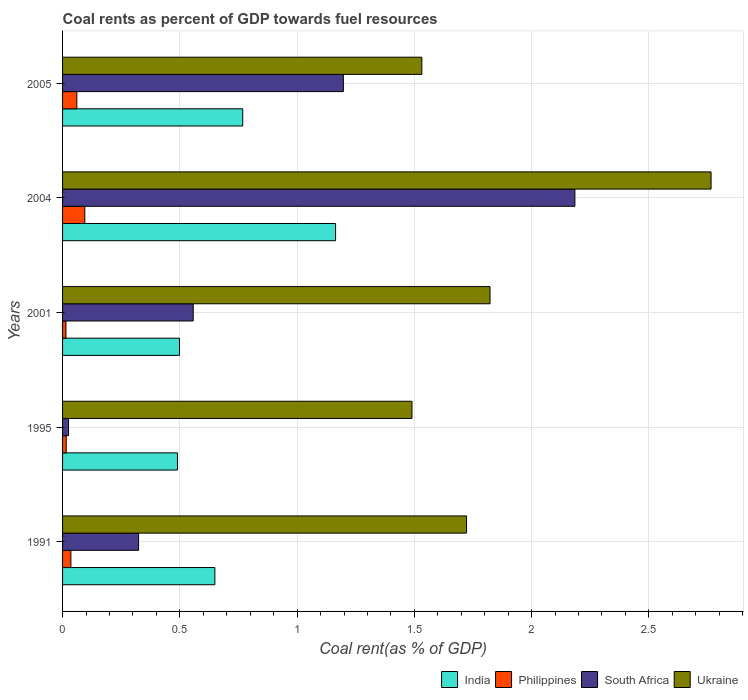How many different coloured bars are there?
Make the answer very short. 4. Are the number of bars on each tick of the Y-axis equal?
Your answer should be compact. Yes. How many bars are there on the 1st tick from the top?
Give a very brief answer. 4. How many bars are there on the 3rd tick from the bottom?
Provide a short and direct response. 4. What is the label of the 3rd group of bars from the top?
Offer a very short reply. 2001. In how many cases, is the number of bars for a given year not equal to the number of legend labels?
Make the answer very short. 0. What is the coal rent in India in 2004?
Your response must be concise. 1.16. Across all years, what is the maximum coal rent in South Africa?
Ensure brevity in your answer.  2.18. Across all years, what is the minimum coal rent in Ukraine?
Your response must be concise. 1.49. In which year was the coal rent in India maximum?
Offer a terse response. 2004. In which year was the coal rent in India minimum?
Make the answer very short. 1995. What is the total coal rent in India in the graph?
Ensure brevity in your answer.  3.57. What is the difference between the coal rent in Philippines in 2004 and that in 2005?
Offer a very short reply. 0.03. What is the difference between the coal rent in Ukraine in 2005 and the coal rent in India in 1991?
Your response must be concise. 0.88. What is the average coal rent in India per year?
Keep it short and to the point. 0.71. In the year 1991, what is the difference between the coal rent in Ukraine and coal rent in India?
Your answer should be compact. 1.07. What is the ratio of the coal rent in Ukraine in 1995 to that in 2001?
Offer a terse response. 0.82. Is the coal rent in Philippines in 1991 less than that in 2005?
Provide a succinct answer. Yes. What is the difference between the highest and the second highest coal rent in Philippines?
Provide a short and direct response. 0.03. What is the difference between the highest and the lowest coal rent in Ukraine?
Give a very brief answer. 1.28. Is the sum of the coal rent in Philippines in 2001 and 2005 greater than the maximum coal rent in Ukraine across all years?
Your answer should be very brief. No. What does the 1st bar from the top in 1995 represents?
Your answer should be very brief. Ukraine. Is it the case that in every year, the sum of the coal rent in Philippines and coal rent in South Africa is greater than the coal rent in Ukraine?
Provide a short and direct response. No. Are all the bars in the graph horizontal?
Your response must be concise. Yes. How many years are there in the graph?
Ensure brevity in your answer.  5. How many legend labels are there?
Keep it short and to the point. 4. How are the legend labels stacked?
Provide a succinct answer. Horizontal. What is the title of the graph?
Your answer should be very brief. Coal rents as percent of GDP towards fuel resources. Does "Equatorial Guinea" appear as one of the legend labels in the graph?
Make the answer very short. No. What is the label or title of the X-axis?
Give a very brief answer. Coal rent(as % of GDP). What is the label or title of the Y-axis?
Make the answer very short. Years. What is the Coal rent(as % of GDP) in India in 1991?
Your response must be concise. 0.65. What is the Coal rent(as % of GDP) of Philippines in 1991?
Provide a succinct answer. 0.04. What is the Coal rent(as % of GDP) of South Africa in 1991?
Give a very brief answer. 0.32. What is the Coal rent(as % of GDP) in Ukraine in 1991?
Your response must be concise. 1.72. What is the Coal rent(as % of GDP) of India in 1995?
Keep it short and to the point. 0.49. What is the Coal rent(as % of GDP) in Philippines in 1995?
Give a very brief answer. 0.02. What is the Coal rent(as % of GDP) in South Africa in 1995?
Your response must be concise. 0.03. What is the Coal rent(as % of GDP) of Ukraine in 1995?
Keep it short and to the point. 1.49. What is the Coal rent(as % of GDP) of India in 2001?
Your answer should be compact. 0.5. What is the Coal rent(as % of GDP) in Philippines in 2001?
Keep it short and to the point. 0.01. What is the Coal rent(as % of GDP) in South Africa in 2001?
Give a very brief answer. 0.56. What is the Coal rent(as % of GDP) of Ukraine in 2001?
Ensure brevity in your answer.  1.82. What is the Coal rent(as % of GDP) in India in 2004?
Make the answer very short. 1.16. What is the Coal rent(as % of GDP) in Philippines in 2004?
Provide a short and direct response. 0.09. What is the Coal rent(as % of GDP) in South Africa in 2004?
Offer a very short reply. 2.18. What is the Coal rent(as % of GDP) in Ukraine in 2004?
Provide a short and direct response. 2.77. What is the Coal rent(as % of GDP) in India in 2005?
Ensure brevity in your answer.  0.77. What is the Coal rent(as % of GDP) of Philippines in 2005?
Keep it short and to the point. 0.06. What is the Coal rent(as % of GDP) of South Africa in 2005?
Make the answer very short. 1.2. What is the Coal rent(as % of GDP) in Ukraine in 2005?
Give a very brief answer. 1.53. Across all years, what is the maximum Coal rent(as % of GDP) of India?
Make the answer very short. 1.16. Across all years, what is the maximum Coal rent(as % of GDP) of Philippines?
Keep it short and to the point. 0.09. Across all years, what is the maximum Coal rent(as % of GDP) of South Africa?
Offer a terse response. 2.18. Across all years, what is the maximum Coal rent(as % of GDP) in Ukraine?
Give a very brief answer. 2.77. Across all years, what is the minimum Coal rent(as % of GDP) in India?
Offer a very short reply. 0.49. Across all years, what is the minimum Coal rent(as % of GDP) of Philippines?
Keep it short and to the point. 0.01. Across all years, what is the minimum Coal rent(as % of GDP) of South Africa?
Provide a short and direct response. 0.03. Across all years, what is the minimum Coal rent(as % of GDP) in Ukraine?
Offer a very short reply. 1.49. What is the total Coal rent(as % of GDP) in India in the graph?
Your answer should be compact. 3.57. What is the total Coal rent(as % of GDP) in Philippines in the graph?
Keep it short and to the point. 0.22. What is the total Coal rent(as % of GDP) of South Africa in the graph?
Your response must be concise. 4.29. What is the total Coal rent(as % of GDP) of Ukraine in the graph?
Provide a short and direct response. 9.33. What is the difference between the Coal rent(as % of GDP) of India in 1991 and that in 1995?
Your response must be concise. 0.16. What is the difference between the Coal rent(as % of GDP) in Philippines in 1991 and that in 1995?
Ensure brevity in your answer.  0.02. What is the difference between the Coal rent(as % of GDP) in South Africa in 1991 and that in 1995?
Keep it short and to the point. 0.3. What is the difference between the Coal rent(as % of GDP) of Ukraine in 1991 and that in 1995?
Provide a succinct answer. 0.23. What is the difference between the Coal rent(as % of GDP) of India in 1991 and that in 2001?
Provide a short and direct response. 0.15. What is the difference between the Coal rent(as % of GDP) of Philippines in 1991 and that in 2001?
Offer a very short reply. 0.02. What is the difference between the Coal rent(as % of GDP) of South Africa in 1991 and that in 2001?
Make the answer very short. -0.23. What is the difference between the Coal rent(as % of GDP) of Ukraine in 1991 and that in 2001?
Your response must be concise. -0.1. What is the difference between the Coal rent(as % of GDP) of India in 1991 and that in 2004?
Ensure brevity in your answer.  -0.51. What is the difference between the Coal rent(as % of GDP) of Philippines in 1991 and that in 2004?
Ensure brevity in your answer.  -0.06. What is the difference between the Coal rent(as % of GDP) of South Africa in 1991 and that in 2004?
Give a very brief answer. -1.86. What is the difference between the Coal rent(as % of GDP) of Ukraine in 1991 and that in 2004?
Your answer should be very brief. -1.04. What is the difference between the Coal rent(as % of GDP) of India in 1991 and that in 2005?
Offer a terse response. -0.12. What is the difference between the Coal rent(as % of GDP) of Philippines in 1991 and that in 2005?
Keep it short and to the point. -0.03. What is the difference between the Coal rent(as % of GDP) of South Africa in 1991 and that in 2005?
Give a very brief answer. -0.87. What is the difference between the Coal rent(as % of GDP) of Ukraine in 1991 and that in 2005?
Provide a succinct answer. 0.19. What is the difference between the Coal rent(as % of GDP) in India in 1995 and that in 2001?
Keep it short and to the point. -0.01. What is the difference between the Coal rent(as % of GDP) in Philippines in 1995 and that in 2001?
Your response must be concise. 0. What is the difference between the Coal rent(as % of GDP) in South Africa in 1995 and that in 2001?
Your response must be concise. -0.53. What is the difference between the Coal rent(as % of GDP) in Ukraine in 1995 and that in 2001?
Offer a very short reply. -0.33. What is the difference between the Coal rent(as % of GDP) in India in 1995 and that in 2004?
Offer a very short reply. -0.67. What is the difference between the Coal rent(as % of GDP) in Philippines in 1995 and that in 2004?
Offer a terse response. -0.08. What is the difference between the Coal rent(as % of GDP) in South Africa in 1995 and that in 2004?
Your answer should be very brief. -2.16. What is the difference between the Coal rent(as % of GDP) of Ukraine in 1995 and that in 2004?
Keep it short and to the point. -1.28. What is the difference between the Coal rent(as % of GDP) of India in 1995 and that in 2005?
Your answer should be compact. -0.28. What is the difference between the Coal rent(as % of GDP) of Philippines in 1995 and that in 2005?
Keep it short and to the point. -0.05. What is the difference between the Coal rent(as % of GDP) in South Africa in 1995 and that in 2005?
Your response must be concise. -1.17. What is the difference between the Coal rent(as % of GDP) in Ukraine in 1995 and that in 2005?
Offer a very short reply. -0.04. What is the difference between the Coal rent(as % of GDP) of India in 2001 and that in 2004?
Your response must be concise. -0.67. What is the difference between the Coal rent(as % of GDP) in Philippines in 2001 and that in 2004?
Provide a succinct answer. -0.08. What is the difference between the Coal rent(as % of GDP) of South Africa in 2001 and that in 2004?
Give a very brief answer. -1.63. What is the difference between the Coal rent(as % of GDP) in Ukraine in 2001 and that in 2004?
Your answer should be compact. -0.94. What is the difference between the Coal rent(as % of GDP) in India in 2001 and that in 2005?
Offer a terse response. -0.27. What is the difference between the Coal rent(as % of GDP) of Philippines in 2001 and that in 2005?
Your response must be concise. -0.05. What is the difference between the Coal rent(as % of GDP) of South Africa in 2001 and that in 2005?
Offer a terse response. -0.64. What is the difference between the Coal rent(as % of GDP) of Ukraine in 2001 and that in 2005?
Offer a very short reply. 0.29. What is the difference between the Coal rent(as % of GDP) of India in 2004 and that in 2005?
Your response must be concise. 0.4. What is the difference between the Coal rent(as % of GDP) in Philippines in 2004 and that in 2005?
Ensure brevity in your answer.  0.03. What is the difference between the Coal rent(as % of GDP) in South Africa in 2004 and that in 2005?
Keep it short and to the point. 0.99. What is the difference between the Coal rent(as % of GDP) of Ukraine in 2004 and that in 2005?
Provide a succinct answer. 1.23. What is the difference between the Coal rent(as % of GDP) in India in 1991 and the Coal rent(as % of GDP) in Philippines in 1995?
Make the answer very short. 0.63. What is the difference between the Coal rent(as % of GDP) in India in 1991 and the Coal rent(as % of GDP) in South Africa in 1995?
Your answer should be compact. 0.62. What is the difference between the Coal rent(as % of GDP) of India in 1991 and the Coal rent(as % of GDP) of Ukraine in 1995?
Offer a terse response. -0.84. What is the difference between the Coal rent(as % of GDP) of Philippines in 1991 and the Coal rent(as % of GDP) of Ukraine in 1995?
Your answer should be compact. -1.45. What is the difference between the Coal rent(as % of GDP) of South Africa in 1991 and the Coal rent(as % of GDP) of Ukraine in 1995?
Your answer should be very brief. -1.17. What is the difference between the Coal rent(as % of GDP) in India in 1991 and the Coal rent(as % of GDP) in Philippines in 2001?
Keep it short and to the point. 0.63. What is the difference between the Coal rent(as % of GDP) in India in 1991 and the Coal rent(as % of GDP) in South Africa in 2001?
Your answer should be compact. 0.09. What is the difference between the Coal rent(as % of GDP) of India in 1991 and the Coal rent(as % of GDP) of Ukraine in 2001?
Keep it short and to the point. -1.17. What is the difference between the Coal rent(as % of GDP) of Philippines in 1991 and the Coal rent(as % of GDP) of South Africa in 2001?
Provide a succinct answer. -0.52. What is the difference between the Coal rent(as % of GDP) of Philippines in 1991 and the Coal rent(as % of GDP) of Ukraine in 2001?
Your answer should be compact. -1.79. What is the difference between the Coal rent(as % of GDP) of South Africa in 1991 and the Coal rent(as % of GDP) of Ukraine in 2001?
Provide a succinct answer. -1.5. What is the difference between the Coal rent(as % of GDP) of India in 1991 and the Coal rent(as % of GDP) of Philippines in 2004?
Make the answer very short. 0.55. What is the difference between the Coal rent(as % of GDP) in India in 1991 and the Coal rent(as % of GDP) in South Africa in 2004?
Offer a terse response. -1.54. What is the difference between the Coal rent(as % of GDP) of India in 1991 and the Coal rent(as % of GDP) of Ukraine in 2004?
Ensure brevity in your answer.  -2.12. What is the difference between the Coal rent(as % of GDP) of Philippines in 1991 and the Coal rent(as % of GDP) of South Africa in 2004?
Your response must be concise. -2.15. What is the difference between the Coal rent(as % of GDP) of Philippines in 1991 and the Coal rent(as % of GDP) of Ukraine in 2004?
Keep it short and to the point. -2.73. What is the difference between the Coal rent(as % of GDP) in South Africa in 1991 and the Coal rent(as % of GDP) in Ukraine in 2004?
Give a very brief answer. -2.44. What is the difference between the Coal rent(as % of GDP) in India in 1991 and the Coal rent(as % of GDP) in Philippines in 2005?
Make the answer very short. 0.59. What is the difference between the Coal rent(as % of GDP) of India in 1991 and the Coal rent(as % of GDP) of South Africa in 2005?
Give a very brief answer. -0.55. What is the difference between the Coal rent(as % of GDP) of India in 1991 and the Coal rent(as % of GDP) of Ukraine in 2005?
Offer a very short reply. -0.88. What is the difference between the Coal rent(as % of GDP) of Philippines in 1991 and the Coal rent(as % of GDP) of South Africa in 2005?
Ensure brevity in your answer.  -1.16. What is the difference between the Coal rent(as % of GDP) in Philippines in 1991 and the Coal rent(as % of GDP) in Ukraine in 2005?
Ensure brevity in your answer.  -1.5. What is the difference between the Coal rent(as % of GDP) of South Africa in 1991 and the Coal rent(as % of GDP) of Ukraine in 2005?
Give a very brief answer. -1.21. What is the difference between the Coal rent(as % of GDP) of India in 1995 and the Coal rent(as % of GDP) of Philippines in 2001?
Give a very brief answer. 0.48. What is the difference between the Coal rent(as % of GDP) of India in 1995 and the Coal rent(as % of GDP) of South Africa in 2001?
Offer a very short reply. -0.07. What is the difference between the Coal rent(as % of GDP) of India in 1995 and the Coal rent(as % of GDP) of Ukraine in 2001?
Your answer should be compact. -1.33. What is the difference between the Coal rent(as % of GDP) in Philippines in 1995 and the Coal rent(as % of GDP) in South Africa in 2001?
Your response must be concise. -0.54. What is the difference between the Coal rent(as % of GDP) in Philippines in 1995 and the Coal rent(as % of GDP) in Ukraine in 2001?
Provide a short and direct response. -1.81. What is the difference between the Coal rent(as % of GDP) of South Africa in 1995 and the Coal rent(as % of GDP) of Ukraine in 2001?
Your answer should be very brief. -1.8. What is the difference between the Coal rent(as % of GDP) in India in 1995 and the Coal rent(as % of GDP) in Philippines in 2004?
Your response must be concise. 0.4. What is the difference between the Coal rent(as % of GDP) of India in 1995 and the Coal rent(as % of GDP) of South Africa in 2004?
Provide a succinct answer. -1.69. What is the difference between the Coal rent(as % of GDP) of India in 1995 and the Coal rent(as % of GDP) of Ukraine in 2004?
Your response must be concise. -2.28. What is the difference between the Coal rent(as % of GDP) in Philippines in 1995 and the Coal rent(as % of GDP) in South Africa in 2004?
Your response must be concise. -2.17. What is the difference between the Coal rent(as % of GDP) in Philippines in 1995 and the Coal rent(as % of GDP) in Ukraine in 2004?
Your answer should be very brief. -2.75. What is the difference between the Coal rent(as % of GDP) of South Africa in 1995 and the Coal rent(as % of GDP) of Ukraine in 2004?
Your response must be concise. -2.74. What is the difference between the Coal rent(as % of GDP) in India in 1995 and the Coal rent(as % of GDP) in Philippines in 2005?
Provide a succinct answer. 0.43. What is the difference between the Coal rent(as % of GDP) of India in 1995 and the Coal rent(as % of GDP) of South Africa in 2005?
Offer a terse response. -0.71. What is the difference between the Coal rent(as % of GDP) of India in 1995 and the Coal rent(as % of GDP) of Ukraine in 2005?
Give a very brief answer. -1.04. What is the difference between the Coal rent(as % of GDP) of Philippines in 1995 and the Coal rent(as % of GDP) of South Africa in 2005?
Provide a succinct answer. -1.18. What is the difference between the Coal rent(as % of GDP) in Philippines in 1995 and the Coal rent(as % of GDP) in Ukraine in 2005?
Give a very brief answer. -1.52. What is the difference between the Coal rent(as % of GDP) of South Africa in 1995 and the Coal rent(as % of GDP) of Ukraine in 2005?
Your answer should be very brief. -1.51. What is the difference between the Coal rent(as % of GDP) in India in 2001 and the Coal rent(as % of GDP) in Philippines in 2004?
Keep it short and to the point. 0.4. What is the difference between the Coal rent(as % of GDP) of India in 2001 and the Coal rent(as % of GDP) of South Africa in 2004?
Offer a terse response. -1.69. What is the difference between the Coal rent(as % of GDP) of India in 2001 and the Coal rent(as % of GDP) of Ukraine in 2004?
Offer a very short reply. -2.27. What is the difference between the Coal rent(as % of GDP) in Philippines in 2001 and the Coal rent(as % of GDP) in South Africa in 2004?
Your answer should be very brief. -2.17. What is the difference between the Coal rent(as % of GDP) in Philippines in 2001 and the Coal rent(as % of GDP) in Ukraine in 2004?
Your answer should be very brief. -2.75. What is the difference between the Coal rent(as % of GDP) of South Africa in 2001 and the Coal rent(as % of GDP) of Ukraine in 2004?
Offer a very short reply. -2.21. What is the difference between the Coal rent(as % of GDP) of India in 2001 and the Coal rent(as % of GDP) of Philippines in 2005?
Give a very brief answer. 0.44. What is the difference between the Coal rent(as % of GDP) in India in 2001 and the Coal rent(as % of GDP) in South Africa in 2005?
Keep it short and to the point. -0.7. What is the difference between the Coal rent(as % of GDP) in India in 2001 and the Coal rent(as % of GDP) in Ukraine in 2005?
Give a very brief answer. -1.03. What is the difference between the Coal rent(as % of GDP) in Philippines in 2001 and the Coal rent(as % of GDP) in South Africa in 2005?
Your answer should be very brief. -1.18. What is the difference between the Coal rent(as % of GDP) of Philippines in 2001 and the Coal rent(as % of GDP) of Ukraine in 2005?
Give a very brief answer. -1.52. What is the difference between the Coal rent(as % of GDP) of South Africa in 2001 and the Coal rent(as % of GDP) of Ukraine in 2005?
Make the answer very short. -0.97. What is the difference between the Coal rent(as % of GDP) of India in 2004 and the Coal rent(as % of GDP) of Philippines in 2005?
Your answer should be very brief. 1.1. What is the difference between the Coal rent(as % of GDP) in India in 2004 and the Coal rent(as % of GDP) in South Africa in 2005?
Ensure brevity in your answer.  -0.03. What is the difference between the Coal rent(as % of GDP) in India in 2004 and the Coal rent(as % of GDP) in Ukraine in 2005?
Offer a terse response. -0.37. What is the difference between the Coal rent(as % of GDP) of Philippines in 2004 and the Coal rent(as % of GDP) of South Africa in 2005?
Offer a very short reply. -1.1. What is the difference between the Coal rent(as % of GDP) in Philippines in 2004 and the Coal rent(as % of GDP) in Ukraine in 2005?
Keep it short and to the point. -1.44. What is the difference between the Coal rent(as % of GDP) of South Africa in 2004 and the Coal rent(as % of GDP) of Ukraine in 2005?
Your answer should be very brief. 0.65. What is the average Coal rent(as % of GDP) in India per year?
Make the answer very short. 0.71. What is the average Coal rent(as % of GDP) of Philippines per year?
Give a very brief answer. 0.04. What is the average Coal rent(as % of GDP) in South Africa per year?
Your response must be concise. 0.86. What is the average Coal rent(as % of GDP) in Ukraine per year?
Keep it short and to the point. 1.87. In the year 1991, what is the difference between the Coal rent(as % of GDP) in India and Coal rent(as % of GDP) in Philippines?
Provide a short and direct response. 0.61. In the year 1991, what is the difference between the Coal rent(as % of GDP) in India and Coal rent(as % of GDP) in South Africa?
Give a very brief answer. 0.33. In the year 1991, what is the difference between the Coal rent(as % of GDP) of India and Coal rent(as % of GDP) of Ukraine?
Ensure brevity in your answer.  -1.07. In the year 1991, what is the difference between the Coal rent(as % of GDP) of Philippines and Coal rent(as % of GDP) of South Africa?
Your response must be concise. -0.29. In the year 1991, what is the difference between the Coal rent(as % of GDP) of Philippines and Coal rent(as % of GDP) of Ukraine?
Your response must be concise. -1.69. In the year 1991, what is the difference between the Coal rent(as % of GDP) in South Africa and Coal rent(as % of GDP) in Ukraine?
Make the answer very short. -1.4. In the year 1995, what is the difference between the Coal rent(as % of GDP) in India and Coal rent(as % of GDP) in Philippines?
Your response must be concise. 0.47. In the year 1995, what is the difference between the Coal rent(as % of GDP) of India and Coal rent(as % of GDP) of South Africa?
Your answer should be very brief. 0.46. In the year 1995, what is the difference between the Coal rent(as % of GDP) of India and Coal rent(as % of GDP) of Ukraine?
Provide a succinct answer. -1. In the year 1995, what is the difference between the Coal rent(as % of GDP) of Philippines and Coal rent(as % of GDP) of South Africa?
Provide a short and direct response. -0.01. In the year 1995, what is the difference between the Coal rent(as % of GDP) in Philippines and Coal rent(as % of GDP) in Ukraine?
Provide a succinct answer. -1.47. In the year 1995, what is the difference between the Coal rent(as % of GDP) in South Africa and Coal rent(as % of GDP) in Ukraine?
Provide a succinct answer. -1.46. In the year 2001, what is the difference between the Coal rent(as % of GDP) in India and Coal rent(as % of GDP) in Philippines?
Your answer should be very brief. 0.48. In the year 2001, what is the difference between the Coal rent(as % of GDP) of India and Coal rent(as % of GDP) of South Africa?
Provide a succinct answer. -0.06. In the year 2001, what is the difference between the Coal rent(as % of GDP) in India and Coal rent(as % of GDP) in Ukraine?
Provide a succinct answer. -1.32. In the year 2001, what is the difference between the Coal rent(as % of GDP) in Philippines and Coal rent(as % of GDP) in South Africa?
Offer a very short reply. -0.54. In the year 2001, what is the difference between the Coal rent(as % of GDP) of Philippines and Coal rent(as % of GDP) of Ukraine?
Ensure brevity in your answer.  -1.81. In the year 2001, what is the difference between the Coal rent(as % of GDP) in South Africa and Coal rent(as % of GDP) in Ukraine?
Your response must be concise. -1.27. In the year 2004, what is the difference between the Coal rent(as % of GDP) in India and Coal rent(as % of GDP) in Philippines?
Offer a terse response. 1.07. In the year 2004, what is the difference between the Coal rent(as % of GDP) of India and Coal rent(as % of GDP) of South Africa?
Keep it short and to the point. -1.02. In the year 2004, what is the difference between the Coal rent(as % of GDP) of India and Coal rent(as % of GDP) of Ukraine?
Provide a short and direct response. -1.6. In the year 2004, what is the difference between the Coal rent(as % of GDP) in Philippines and Coal rent(as % of GDP) in South Africa?
Offer a terse response. -2.09. In the year 2004, what is the difference between the Coal rent(as % of GDP) of Philippines and Coal rent(as % of GDP) of Ukraine?
Provide a short and direct response. -2.67. In the year 2004, what is the difference between the Coal rent(as % of GDP) of South Africa and Coal rent(as % of GDP) of Ukraine?
Your answer should be very brief. -0.58. In the year 2005, what is the difference between the Coal rent(as % of GDP) in India and Coal rent(as % of GDP) in Philippines?
Offer a terse response. 0.71. In the year 2005, what is the difference between the Coal rent(as % of GDP) in India and Coal rent(as % of GDP) in South Africa?
Your answer should be very brief. -0.43. In the year 2005, what is the difference between the Coal rent(as % of GDP) in India and Coal rent(as % of GDP) in Ukraine?
Make the answer very short. -0.76. In the year 2005, what is the difference between the Coal rent(as % of GDP) in Philippines and Coal rent(as % of GDP) in South Africa?
Make the answer very short. -1.14. In the year 2005, what is the difference between the Coal rent(as % of GDP) in Philippines and Coal rent(as % of GDP) in Ukraine?
Your answer should be compact. -1.47. In the year 2005, what is the difference between the Coal rent(as % of GDP) in South Africa and Coal rent(as % of GDP) in Ukraine?
Provide a short and direct response. -0.33. What is the ratio of the Coal rent(as % of GDP) in India in 1991 to that in 1995?
Your answer should be compact. 1.33. What is the ratio of the Coal rent(as % of GDP) of Philippines in 1991 to that in 1995?
Offer a terse response. 2.28. What is the ratio of the Coal rent(as % of GDP) in South Africa in 1991 to that in 1995?
Provide a short and direct response. 12.72. What is the ratio of the Coal rent(as % of GDP) of Ukraine in 1991 to that in 1995?
Ensure brevity in your answer.  1.16. What is the ratio of the Coal rent(as % of GDP) of India in 1991 to that in 2001?
Give a very brief answer. 1.3. What is the ratio of the Coal rent(as % of GDP) of Philippines in 1991 to that in 2001?
Give a very brief answer. 2.45. What is the ratio of the Coal rent(as % of GDP) of South Africa in 1991 to that in 2001?
Give a very brief answer. 0.58. What is the ratio of the Coal rent(as % of GDP) in Ukraine in 1991 to that in 2001?
Your answer should be compact. 0.95. What is the ratio of the Coal rent(as % of GDP) in India in 1991 to that in 2004?
Your answer should be very brief. 0.56. What is the ratio of the Coal rent(as % of GDP) in Philippines in 1991 to that in 2004?
Your answer should be compact. 0.38. What is the ratio of the Coal rent(as % of GDP) of South Africa in 1991 to that in 2004?
Offer a terse response. 0.15. What is the ratio of the Coal rent(as % of GDP) in Ukraine in 1991 to that in 2004?
Keep it short and to the point. 0.62. What is the ratio of the Coal rent(as % of GDP) in India in 1991 to that in 2005?
Your response must be concise. 0.85. What is the ratio of the Coal rent(as % of GDP) in Philippines in 1991 to that in 2005?
Your response must be concise. 0.58. What is the ratio of the Coal rent(as % of GDP) of South Africa in 1991 to that in 2005?
Your answer should be compact. 0.27. What is the ratio of the Coal rent(as % of GDP) of Ukraine in 1991 to that in 2005?
Keep it short and to the point. 1.12. What is the ratio of the Coal rent(as % of GDP) of India in 1995 to that in 2001?
Provide a succinct answer. 0.98. What is the ratio of the Coal rent(as % of GDP) of Philippines in 1995 to that in 2001?
Your answer should be compact. 1.08. What is the ratio of the Coal rent(as % of GDP) of South Africa in 1995 to that in 2001?
Your response must be concise. 0.05. What is the ratio of the Coal rent(as % of GDP) of Ukraine in 1995 to that in 2001?
Make the answer very short. 0.82. What is the ratio of the Coal rent(as % of GDP) of India in 1995 to that in 2004?
Your answer should be compact. 0.42. What is the ratio of the Coal rent(as % of GDP) in Philippines in 1995 to that in 2004?
Offer a very short reply. 0.16. What is the ratio of the Coal rent(as % of GDP) in South Africa in 1995 to that in 2004?
Ensure brevity in your answer.  0.01. What is the ratio of the Coal rent(as % of GDP) of Ukraine in 1995 to that in 2004?
Your answer should be compact. 0.54. What is the ratio of the Coal rent(as % of GDP) of India in 1995 to that in 2005?
Give a very brief answer. 0.64. What is the ratio of the Coal rent(as % of GDP) of Philippines in 1995 to that in 2005?
Offer a terse response. 0.26. What is the ratio of the Coal rent(as % of GDP) of South Africa in 1995 to that in 2005?
Keep it short and to the point. 0.02. What is the ratio of the Coal rent(as % of GDP) in Ukraine in 1995 to that in 2005?
Your answer should be compact. 0.97. What is the ratio of the Coal rent(as % of GDP) in India in 2001 to that in 2004?
Ensure brevity in your answer.  0.43. What is the ratio of the Coal rent(as % of GDP) of Philippines in 2001 to that in 2004?
Make the answer very short. 0.15. What is the ratio of the Coal rent(as % of GDP) in South Africa in 2001 to that in 2004?
Your response must be concise. 0.26. What is the ratio of the Coal rent(as % of GDP) in Ukraine in 2001 to that in 2004?
Offer a terse response. 0.66. What is the ratio of the Coal rent(as % of GDP) of India in 2001 to that in 2005?
Provide a short and direct response. 0.65. What is the ratio of the Coal rent(as % of GDP) of Philippines in 2001 to that in 2005?
Make the answer very short. 0.24. What is the ratio of the Coal rent(as % of GDP) of South Africa in 2001 to that in 2005?
Your answer should be very brief. 0.47. What is the ratio of the Coal rent(as % of GDP) of Ukraine in 2001 to that in 2005?
Make the answer very short. 1.19. What is the ratio of the Coal rent(as % of GDP) of India in 2004 to that in 2005?
Your response must be concise. 1.52. What is the ratio of the Coal rent(as % of GDP) of Philippines in 2004 to that in 2005?
Ensure brevity in your answer.  1.56. What is the ratio of the Coal rent(as % of GDP) in South Africa in 2004 to that in 2005?
Your answer should be very brief. 1.82. What is the ratio of the Coal rent(as % of GDP) in Ukraine in 2004 to that in 2005?
Ensure brevity in your answer.  1.8. What is the difference between the highest and the second highest Coal rent(as % of GDP) of India?
Offer a very short reply. 0.4. What is the difference between the highest and the second highest Coal rent(as % of GDP) of Philippines?
Provide a succinct answer. 0.03. What is the difference between the highest and the second highest Coal rent(as % of GDP) of South Africa?
Your answer should be very brief. 0.99. What is the difference between the highest and the second highest Coal rent(as % of GDP) in Ukraine?
Offer a very short reply. 0.94. What is the difference between the highest and the lowest Coal rent(as % of GDP) of India?
Offer a terse response. 0.67. What is the difference between the highest and the lowest Coal rent(as % of GDP) in Philippines?
Give a very brief answer. 0.08. What is the difference between the highest and the lowest Coal rent(as % of GDP) of South Africa?
Ensure brevity in your answer.  2.16. What is the difference between the highest and the lowest Coal rent(as % of GDP) in Ukraine?
Your answer should be very brief. 1.28. 